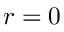Convert formula to latex. <formula><loc_0><loc_0><loc_500><loc_500>r = 0</formula> 